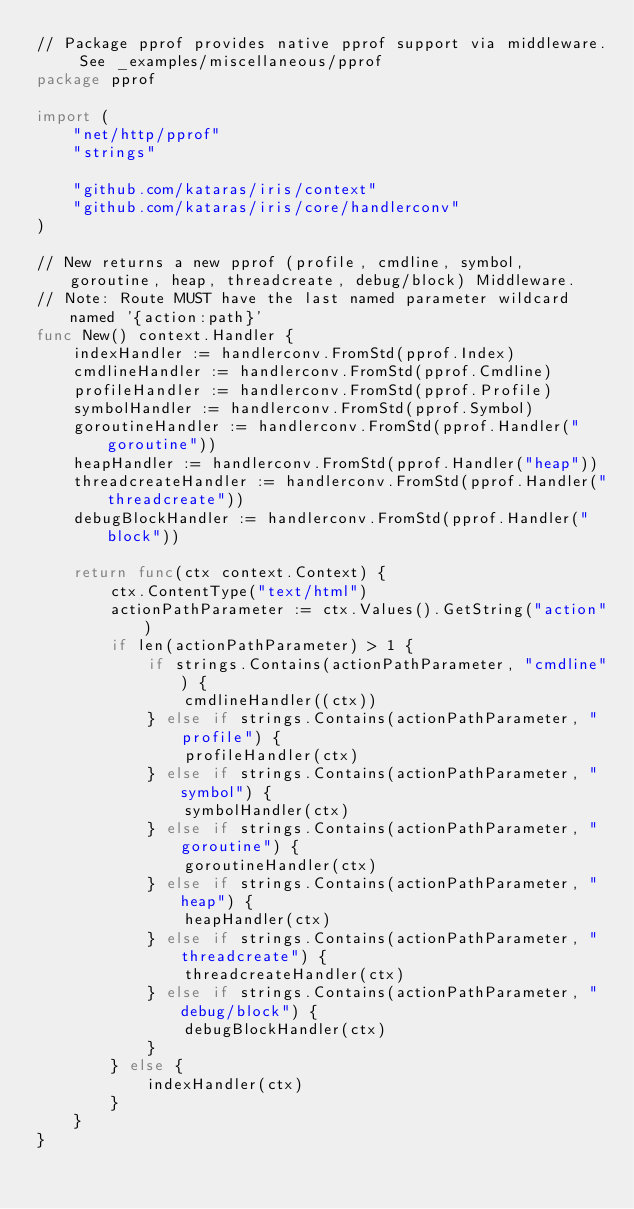Convert code to text. <code><loc_0><loc_0><loc_500><loc_500><_Go_>// Package pprof provides native pprof support via middleware. See _examples/miscellaneous/pprof
package pprof

import (
	"net/http/pprof"
	"strings"

	"github.com/kataras/iris/context"
	"github.com/kataras/iris/core/handlerconv"
)

// New returns a new pprof (profile, cmdline, symbol, goroutine, heap, threadcreate, debug/block) Middleware.
// Note: Route MUST have the last named parameter wildcard named '{action:path}'
func New() context.Handler {
	indexHandler := handlerconv.FromStd(pprof.Index)
	cmdlineHandler := handlerconv.FromStd(pprof.Cmdline)
	profileHandler := handlerconv.FromStd(pprof.Profile)
	symbolHandler := handlerconv.FromStd(pprof.Symbol)
	goroutineHandler := handlerconv.FromStd(pprof.Handler("goroutine"))
	heapHandler := handlerconv.FromStd(pprof.Handler("heap"))
	threadcreateHandler := handlerconv.FromStd(pprof.Handler("threadcreate"))
	debugBlockHandler := handlerconv.FromStd(pprof.Handler("block"))

	return func(ctx context.Context) {
		ctx.ContentType("text/html")
		actionPathParameter := ctx.Values().GetString("action")
		if len(actionPathParameter) > 1 {
			if strings.Contains(actionPathParameter, "cmdline") {
				cmdlineHandler((ctx))
			} else if strings.Contains(actionPathParameter, "profile") {
				profileHandler(ctx)
			} else if strings.Contains(actionPathParameter, "symbol") {
				symbolHandler(ctx)
			} else if strings.Contains(actionPathParameter, "goroutine") {
				goroutineHandler(ctx)
			} else if strings.Contains(actionPathParameter, "heap") {
				heapHandler(ctx)
			} else if strings.Contains(actionPathParameter, "threadcreate") {
				threadcreateHandler(ctx)
			} else if strings.Contains(actionPathParameter, "debug/block") {
				debugBlockHandler(ctx)
			}
		} else {
			indexHandler(ctx)
		}
	}
}
</code> 